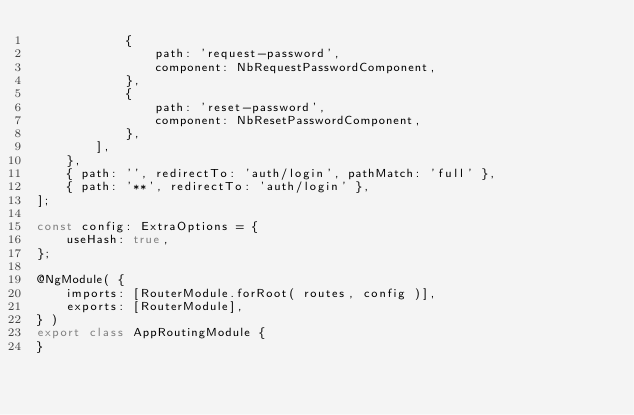<code> <loc_0><loc_0><loc_500><loc_500><_TypeScript_>            {
                path: 'request-password',
                component: NbRequestPasswordComponent,
            },
            {
                path: 'reset-password',
                component: NbResetPasswordComponent,
            },
        ],
    },
    { path: '', redirectTo: 'auth/login', pathMatch: 'full' },
    { path: '**', redirectTo: 'auth/login' },
];

const config: ExtraOptions = {
    useHash: true,
};

@NgModule( {
    imports: [RouterModule.forRoot( routes, config )],
    exports: [RouterModule],
} )
export class AppRoutingModule {
}
</code> 